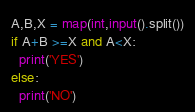Convert code to text. <code><loc_0><loc_0><loc_500><loc_500><_Python_>A,B,X = map(int,input().split())
if A+B >=X and A<X:
  print('YES')
else:
  print('NO')</code> 